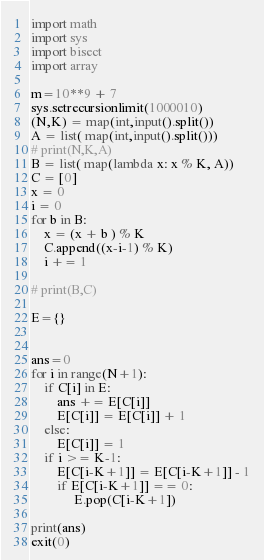Convert code to text. <code><loc_0><loc_0><loc_500><loc_500><_Python_>import math
import sys
import bisect
import array

m=10**9 + 7 
sys.setrecursionlimit(1000010)
(N,K) = map(int,input().split())
A = list( map(int,input().split())) 
# print(N,K,A)
B = list( map(lambda x: x % K, A))
C = [0]
x = 0
i = 0 
for b in B:
    x = (x + b ) % K 
    C.append((x-i-1) % K) 
    i += 1 
    
# print(B,C)

E={}


ans=0
for i in range(N+1):
    if C[i] in E:
        ans += E[C[i]]
        E[C[i]] = E[C[i]] + 1
    else:
        E[C[i]] = 1
    if i >= K-1:
        E[C[i-K+1]] = E[C[i-K+1]] - 1
        if E[C[i-K+1]] == 0:
             E.pop(C[i-K+1])

print(ans)
exit(0)</code> 